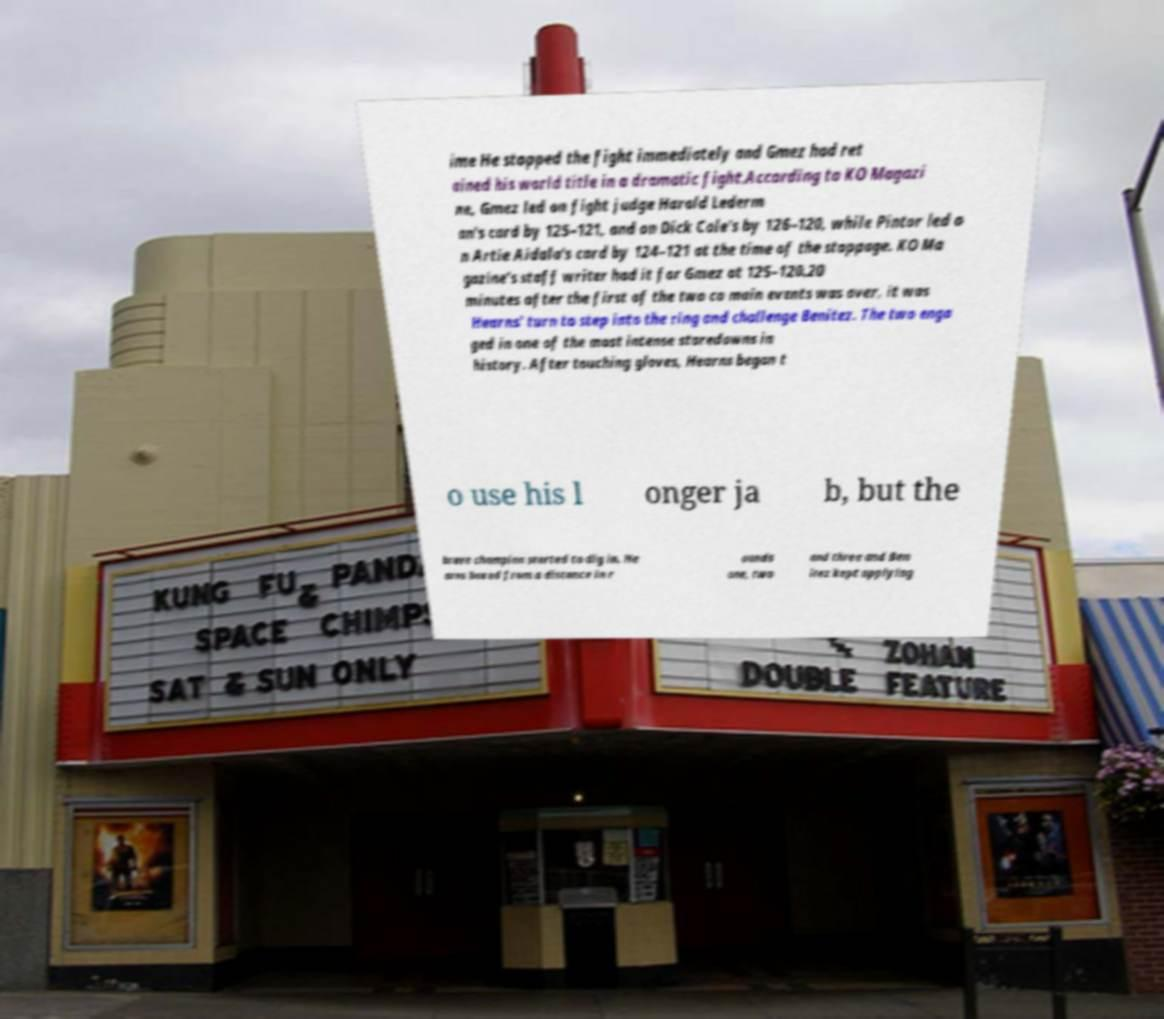Can you read and provide the text displayed in the image?This photo seems to have some interesting text. Can you extract and type it out for me? ime He stopped the fight immediately and Gmez had ret ained his world title in a dramatic fight.According to KO Magazi ne, Gmez led on fight judge Harold Lederm an's card by 125–121, and on Dick Cole's by 126–120, while Pintor led o n Artie Aidala's card by 124–121 at the time of the stoppage. KO Ma gazine's staff writer had it for Gmez at 125–120.20 minutes after the first of the two co main events was over, it was Hearns' turn to step into the ring and challenge Benitez. The two enga ged in one of the most intense staredowns in history. After touching gloves, Hearns began t o use his l onger ja b, but the brave champion started to dig in. He arns boxed from a distance in r ounds one, two and three and Ben itez kept applying 